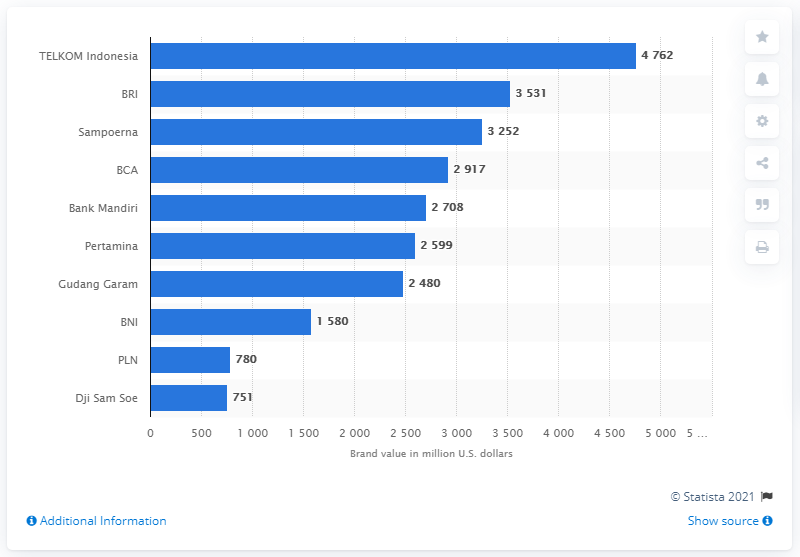Draw attention to some important aspects in this diagram. In 2020, Telkom Indonesia's brand value was estimated to be approximately 4,762 dollars. 